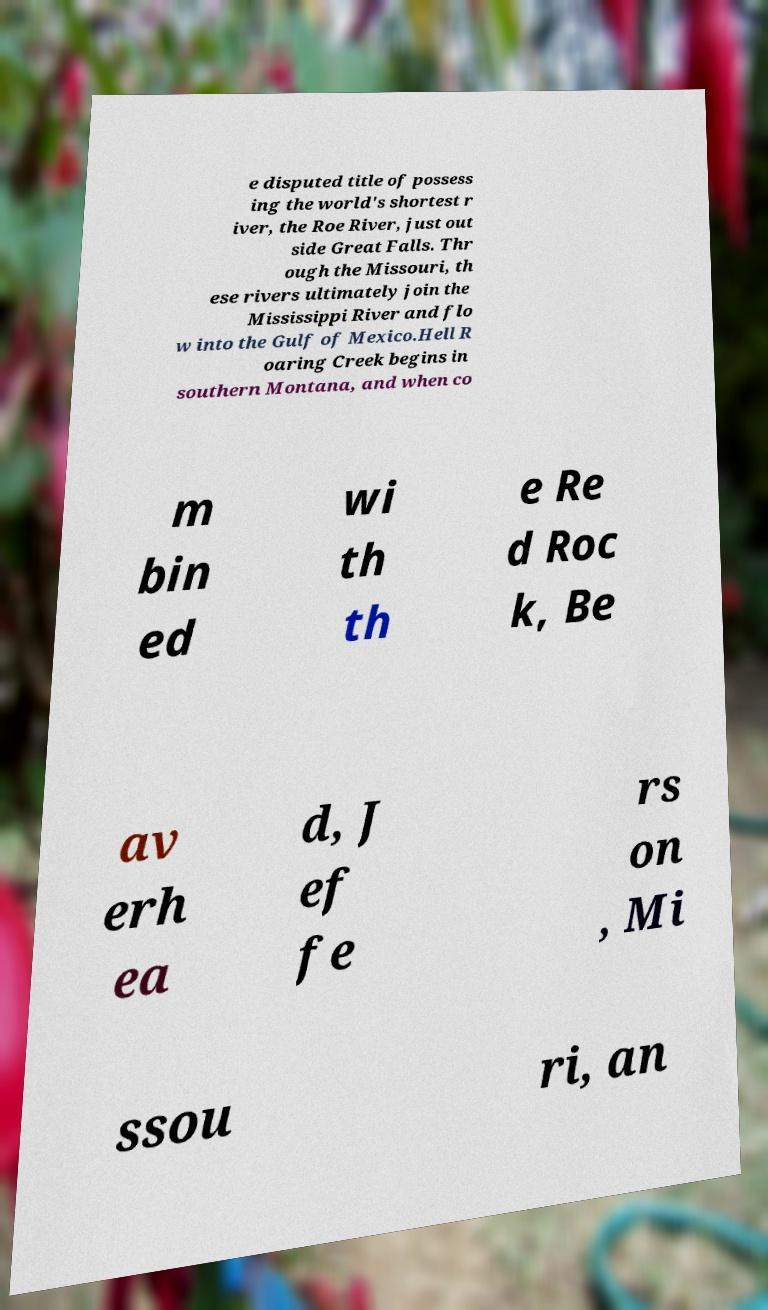Can you read and provide the text displayed in the image?This photo seems to have some interesting text. Can you extract and type it out for me? e disputed title of possess ing the world's shortest r iver, the Roe River, just out side Great Falls. Thr ough the Missouri, th ese rivers ultimately join the Mississippi River and flo w into the Gulf of Mexico.Hell R oaring Creek begins in southern Montana, and when co m bin ed wi th th e Re d Roc k, Be av erh ea d, J ef fe rs on , Mi ssou ri, an 